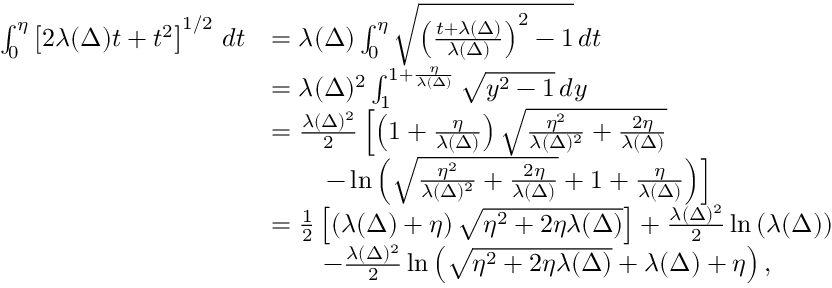Convert formula to latex. <formula><loc_0><loc_0><loc_500><loc_500>\begin{array} { r l } { \int _ { 0 } ^ { \eta } \left [ 2 \lambda ( \Delta ) t + t ^ { 2 } \right ] ^ { 1 / 2 } \, d t } & { = \lambda ( \Delta ) \int _ { 0 } ^ { \eta } \sqrt { \left ( \frac { t + \lambda ( \Delta ) } { \lambda ( \Delta ) } \right ) ^ { 2 } - 1 } \, d t } \\ & { = \lambda ( \Delta ) ^ { 2 } \int _ { 1 } ^ { 1 + \frac { \eta } { \lambda ( \Delta ) } } \sqrt { y ^ { 2 } - 1 } \, d y } \\ & { = \frac { \lambda ( \Delta ) ^ { 2 } } { 2 } \left [ \left ( 1 + \frac { \eta } { \lambda ( \Delta ) } \right ) \sqrt { \frac { \eta ^ { 2 } } { \lambda ( \Delta ) ^ { 2 } } + \frac { 2 \eta } { \lambda ( \Delta ) } } } \\ & { \quad - \ln \left ( \sqrt { \frac { \eta ^ { 2 } } { \lambda ( \Delta ) ^ { 2 } } + \frac { 2 \eta } { \lambda ( \Delta ) } } + 1 + \frac { \eta } { \lambda ( \Delta ) } \right ) \right ] } \\ & { = \frac { 1 } { 2 } \left [ \left ( \lambda ( \Delta ) + \eta \right ) \sqrt { \eta ^ { 2 } + 2 \eta \lambda ( \Delta ) } \right ] + \frac { \lambda ( \Delta ) ^ { 2 } } { 2 } \ln \left ( \lambda ( \Delta ) \right ) } \\ & { \quad - \frac { \lambda ( \Delta ) ^ { 2 } } { 2 } \ln \left ( \sqrt { \eta ^ { 2 } + 2 \eta \lambda ( \Delta ) } + \lambda ( \Delta ) + \eta \right ) , } \end{array}</formula> 